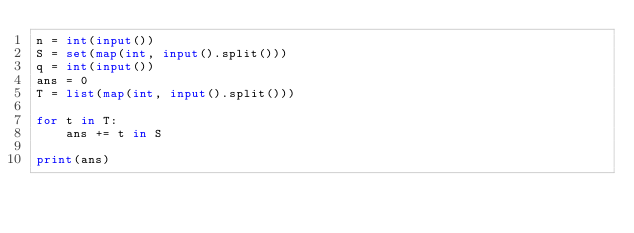Convert code to text. <code><loc_0><loc_0><loc_500><loc_500><_Python_>n = int(input())
S = set(map(int, input().split()))
q = int(input())
ans = 0
T = list(map(int, input().split()))

for t in T:
    ans += t in S
    
print(ans)
</code> 